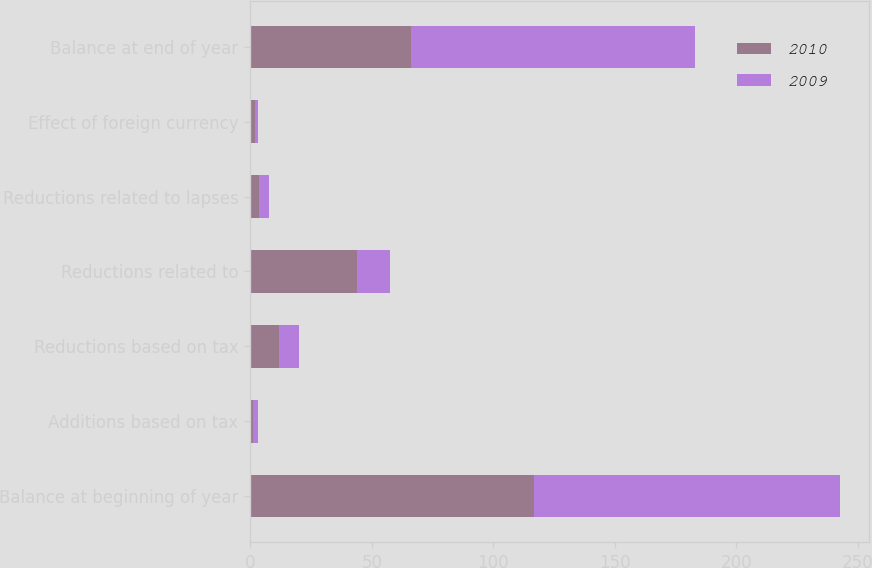<chart> <loc_0><loc_0><loc_500><loc_500><stacked_bar_chart><ecel><fcel>Balance at beginning of year<fcel>Additions based on tax<fcel>Reductions based on tax<fcel>Reductions related to<fcel>Reductions related to lapses<fcel>Effect of foreign currency<fcel>Balance at end of year<nl><fcel>2010<fcel>116.7<fcel>1<fcel>12<fcel>44<fcel>3.7<fcel>2<fcel>66.3<nl><fcel>2009<fcel>125.8<fcel>2.2<fcel>8.1<fcel>13.3<fcel>3.9<fcel>1.3<fcel>116.7<nl></chart> 